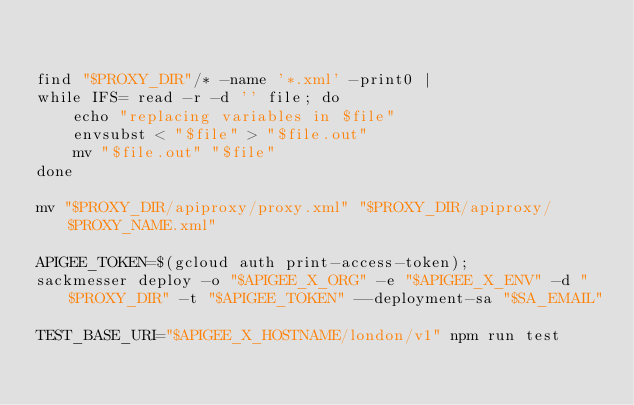Convert code to text. <code><loc_0><loc_0><loc_500><loc_500><_Bash_>

find "$PROXY_DIR"/* -name '*.xml' -print0 |
while IFS= read -r -d '' file; do
    echo "replacing variables in $file"
    envsubst < "$file" > "$file.out"
    mv "$file.out" "$file"
done

mv "$PROXY_DIR/apiproxy/proxy.xml" "$PROXY_DIR/apiproxy/$PROXY_NAME.xml"

APIGEE_TOKEN=$(gcloud auth print-access-token);
sackmesser deploy -o "$APIGEE_X_ORG" -e "$APIGEE_X_ENV" -d "$PROXY_DIR" -t "$APIGEE_TOKEN" --deployment-sa "$SA_EMAIL"

TEST_BASE_URI="$APIGEE_X_HOSTNAME/london/v1" npm run test
</code> 